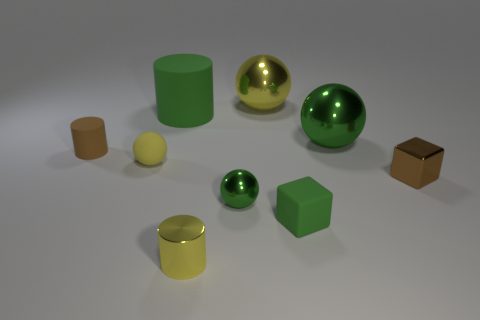Do the large yellow ball and the big green cylinder have the same material?
Keep it short and to the point. No. How many big cylinders are the same color as the rubber cube?
Offer a very short reply. 1. Is the rubber cube the same color as the large cylinder?
Keep it short and to the point. Yes. There is a small cube in front of the metal cube; what material is it?
Provide a succinct answer. Rubber. How many large things are either metal balls or green metal balls?
Your answer should be very brief. 2. There is a tiny sphere that is the same color as the metallic cylinder; what is it made of?
Provide a short and direct response. Rubber. Are there any big blue blocks made of the same material as the large green cylinder?
Keep it short and to the point. No. Is the size of the cylinder that is in front of the brown matte object the same as the tiny green ball?
Make the answer very short. Yes. Is there a large yellow object that is behind the large ball behind the rubber cylinder behind the tiny brown cylinder?
Provide a short and direct response. No. How many rubber objects are either tiny brown things or gray cubes?
Offer a very short reply. 1. 